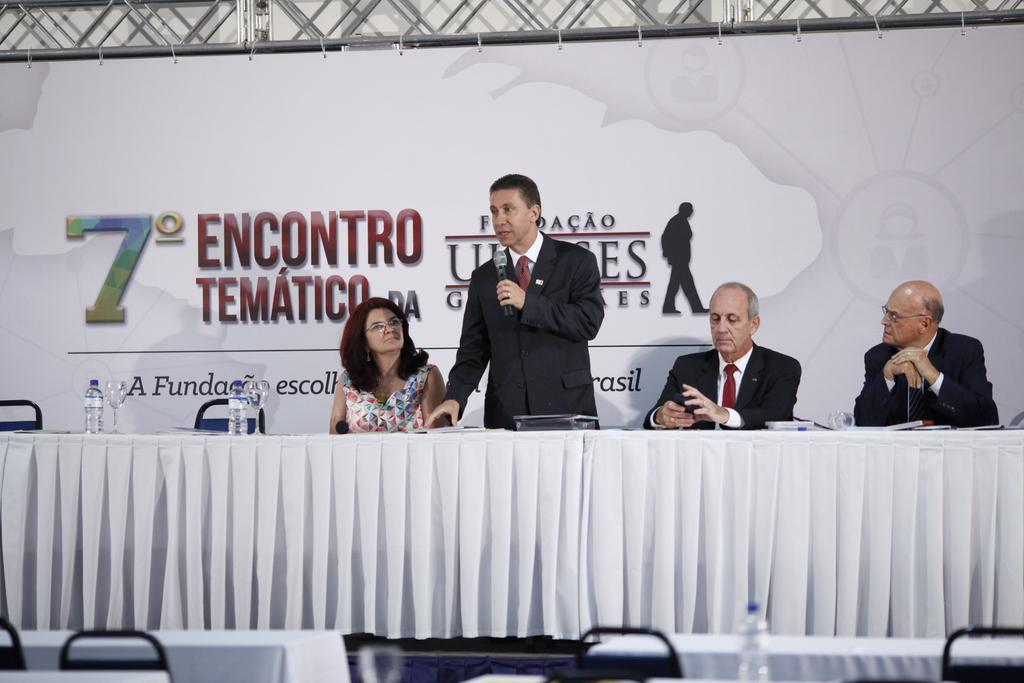What are the people in the image doing? The people in the image are sitting on chairs. What is the man in the image doing? The man in the image is standing and holding a microphone in his hand. What type of turkey can be seen in the image? There is no turkey present in the image. What thoughts are going through the man's mind as he holds the microphone? We cannot determine the man's thoughts from the image alone, as thoughts are not visible. 